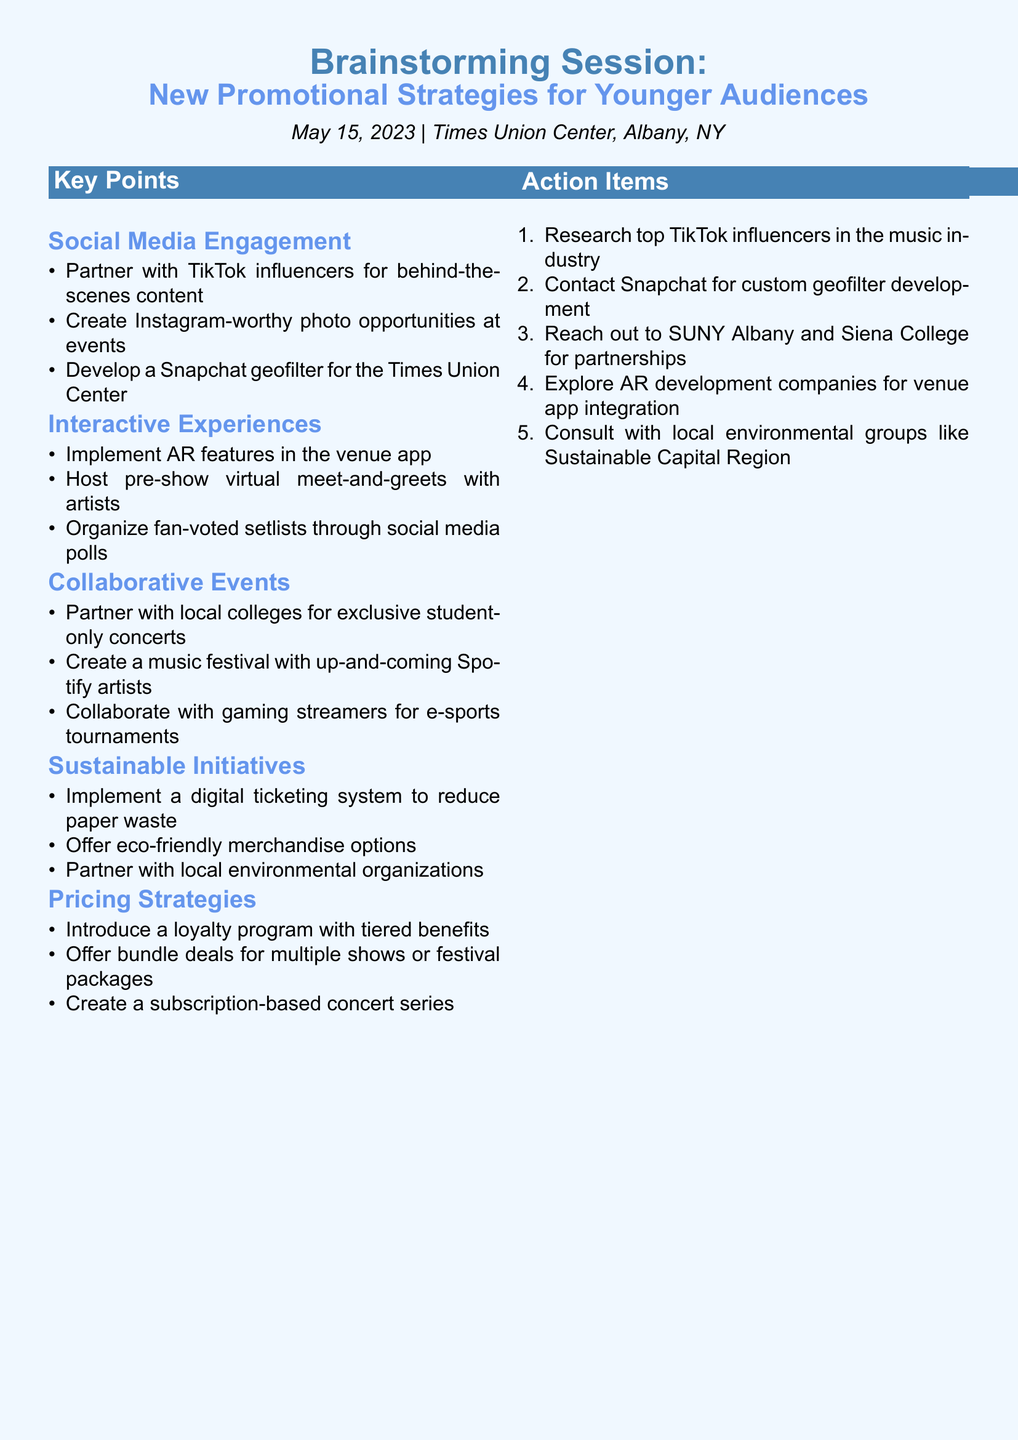What date was the brainstorming session held? The date is mentioned in the document as May 15, 2023.
Answer: May 15, 2023 Where was the brainstorming session conducted? The location of the session is provided in the document as Times Union Center, Albany, NY.
Answer: Times Union Center, Albany, NY What is one proposed strategy for social media engagement? A specific idea under social media engagement can be found in the document, such as partnering with TikTok influencers.
Answer: Partner with TikTok influencers for behind-the-scenes content What category includes ideas about partnering with local colleges? The document categorizes this idea under Collaborative Events.
Answer: Collaborative Events What is one of the action items listed in the document? Several action items are provided, one of which is to research TikTok influencers in the music industry.
Answer: Research top TikTok influencers in the music industry How many key categories of promotional strategies are discussed? The document lists five distinct categories of promotional strategies.
Answer: Five 